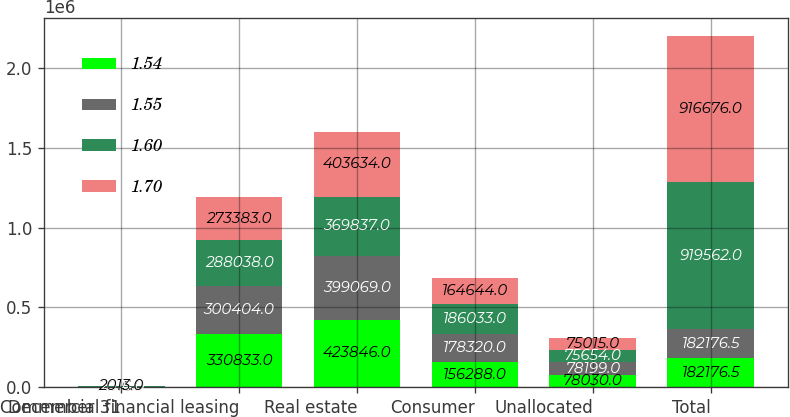<chart> <loc_0><loc_0><loc_500><loc_500><stacked_bar_chart><ecel><fcel>December 31<fcel>Commercial financial leasing<fcel>Real estate<fcel>Consumer<fcel>Unallocated<fcel>Total<nl><fcel>1.54<fcel>2016<fcel>330833<fcel>423846<fcel>156288<fcel>78030<fcel>182176<nl><fcel>1.55<fcel>2015<fcel>300404<fcel>399069<fcel>178320<fcel>78199<fcel>182176<nl><fcel>1.6<fcel>2014<fcel>288038<fcel>369837<fcel>186033<fcel>75654<fcel>919562<nl><fcel>1.7<fcel>2013<fcel>273383<fcel>403634<fcel>164644<fcel>75015<fcel>916676<nl></chart> 